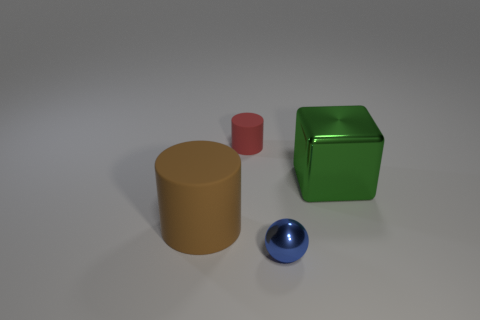There is a green cube; how many small cylinders are on the right side of it?
Offer a very short reply. 0. What is the shape of the large brown object that is the same material as the red cylinder?
Provide a succinct answer. Cylinder. Is the number of matte objects that are in front of the big cylinder less than the number of things that are behind the green shiny cube?
Your answer should be very brief. Yes. Are there more red matte objects than big red matte blocks?
Your response must be concise. Yes. What material is the big cube?
Your answer should be very brief. Metal. What color is the shiny thing that is in front of the big green thing?
Offer a terse response. Blue. Is the number of brown rubber objects in front of the blue object greater than the number of blue balls to the right of the block?
Your answer should be compact. No. What is the size of the rubber thing right of the cylinder in front of the small object behind the large cube?
Offer a terse response. Small. Is there another ball of the same color as the tiny ball?
Give a very brief answer. No. How many objects are there?
Your answer should be compact. 4. 